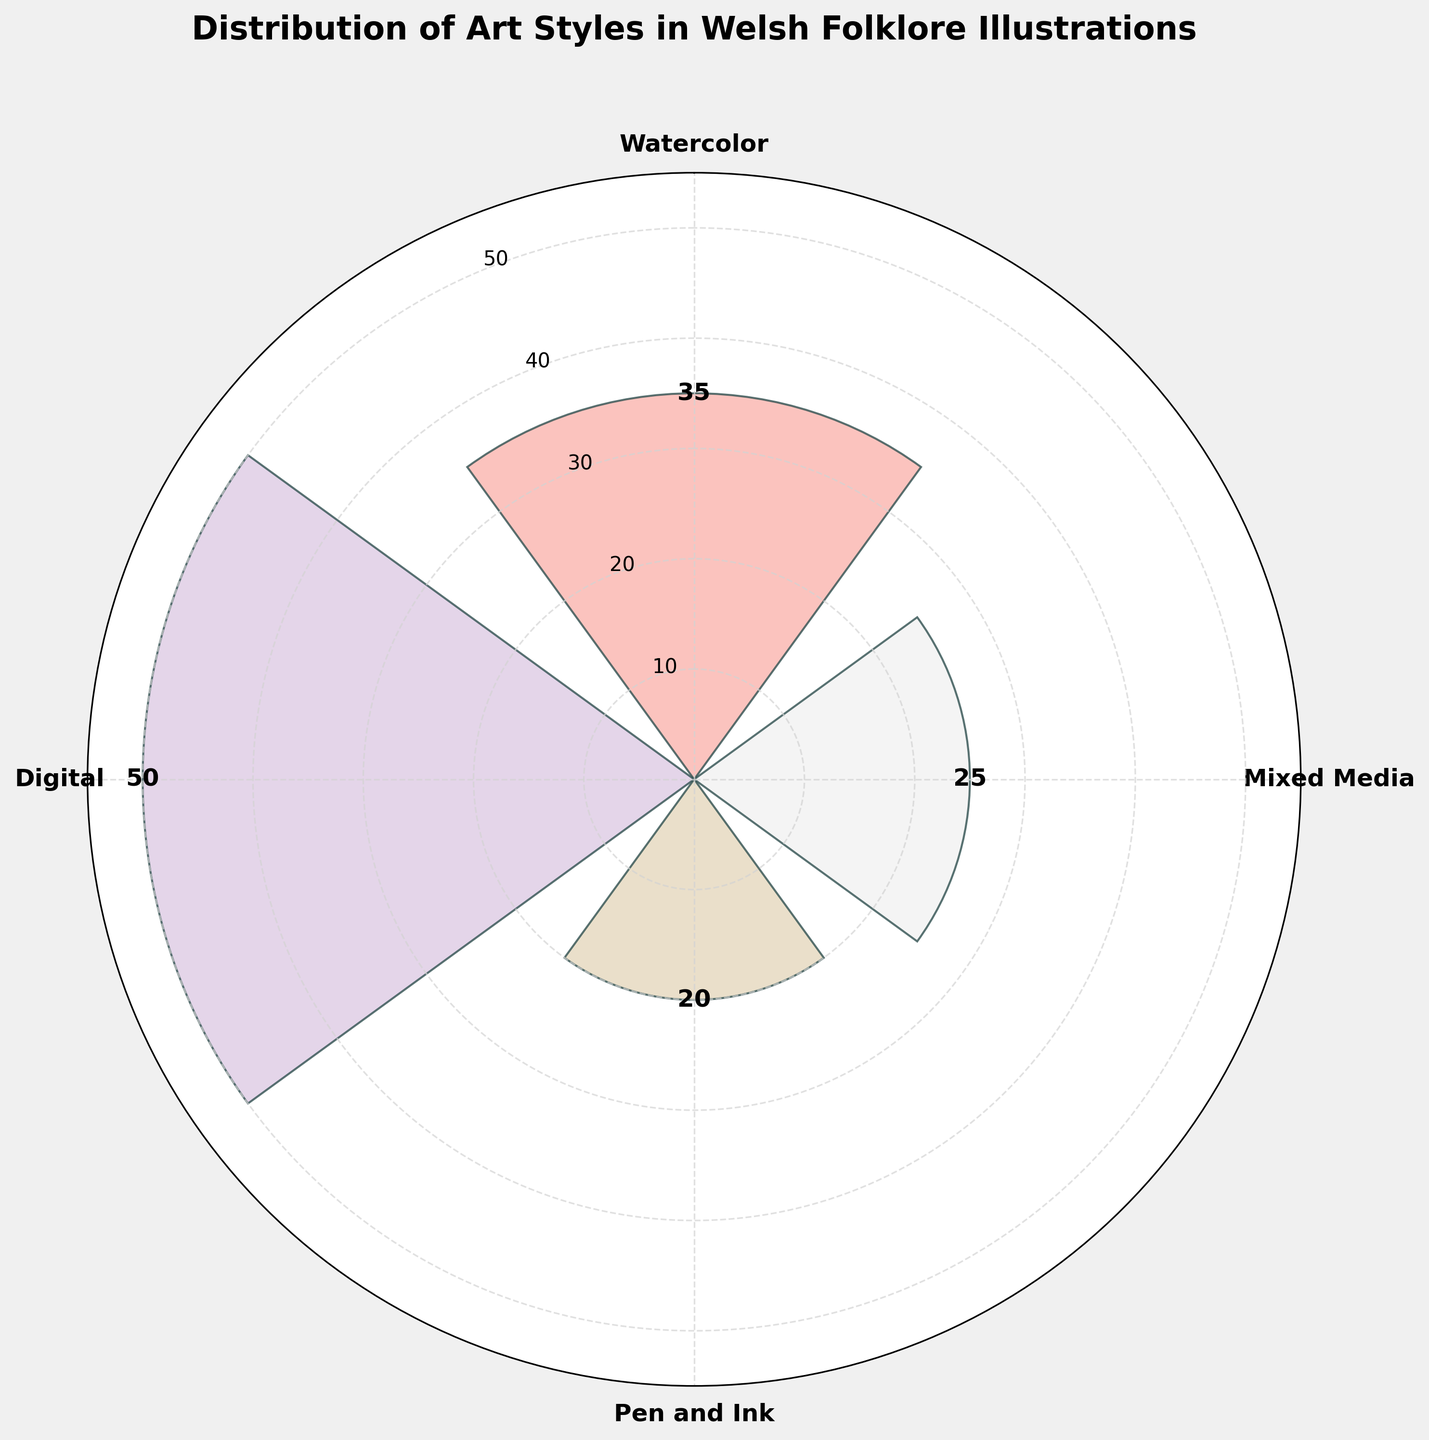Which art style is used the most in Welsh folklore illustrations? From the rose chart, the length of each bar corresponds to the frequency of each art style. The longest bar represents the "Digital" art style with a frequency of 50, making it the most used art style.
Answer: Digital What is the frequency of Watercolor art style? The bar labeled "Watercolor" in the rose chart has a value label of 35, indicating that the frequency is 35.
Answer: 35 How do the frequencies of "Pen and Ink" and "Mixed Media" compare? The rose chart shows that the "Pen and Ink" bar has a value of 20, while the "Mixed Media" bar has a value of 25. Therefore, "Mixed Media" is used more frequently than "Pen and Ink".
Answer: Mixed Media > Pen and Ink What is the difference in frequency between the most and least used art styles? The most used art style is "Digital" with a frequency of 50, and the least used is "Pen and Ink" with a frequency of 20. The difference is calculated as 50 - 20 = 30.
Answer: 30 Which two art styles have the closest frequencies? Comparing the frequencies, Watercolor (35) and Mixed Media (25) are the two closest, with a difference of 10.
Answer: Watercolor and Mixed Media What's the sum of the frequencies of "Watercolor" and "Pen and Ink"? "Watercolor" has a frequency of 35 and "Pen and Ink" has a frequency of 20. The sum is 35 + 20 = 55.
Answer: 55 What's the average frequency of all art styles? Adding up all frequencies: 35 (Watercolor) + 50 (Digital) + 20 (Pen and Ink) + 25 (Mixed Media) = 130. With 4 art styles, the average is 130 / 4 = 32.5.
Answer: 32.5 Does any art style have exactly half the frequency of another? By inspecting the values: Digital (50), Watercolor is 35 (not half of 50), Pen and Ink is 20 (half of 40, not 50), Mixed Media is 25 (half of 50). Therefore, Mixed Media has half the frequency of Digital.
Answer: Yes, Mixed Media is half of Digital Which art style shows a frequency 10 more than "Pen and Ink"? In "Pen and Ink," the frequency is 20. Adding 10 gives 30, and the "Mixed Media" bar has a frequency of 25, not 30. Thus, no art style shows exactly 10 more than "Pen and Ink".
Answer: None 